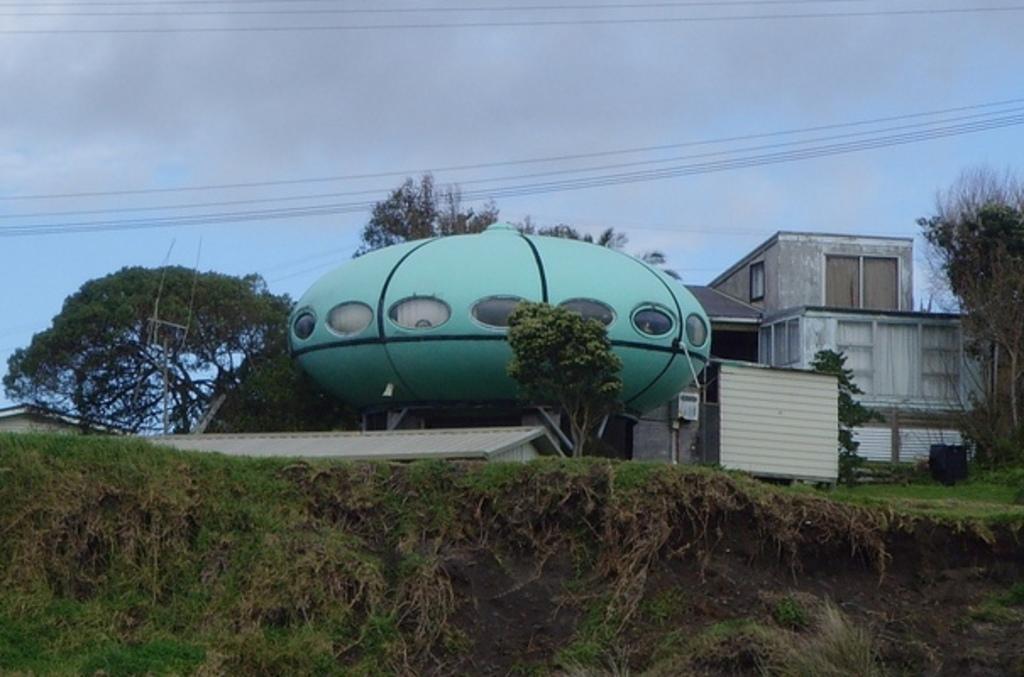Could you give a brief overview of what you see in this image? In this picture we can see buildings with windows, trees, wires and in the background we can see sky with clouds. 